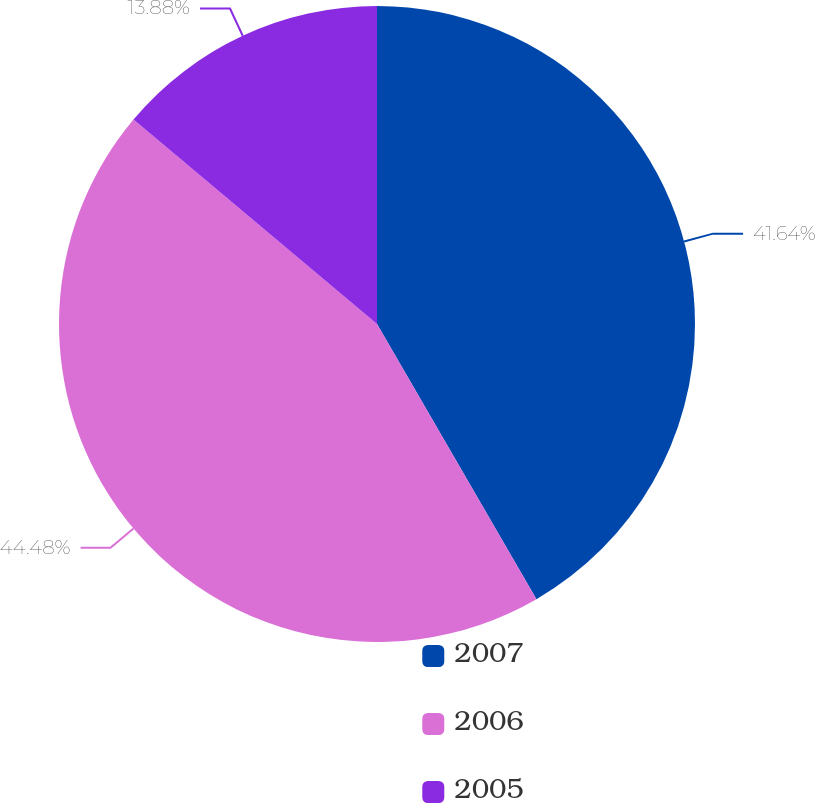<chart> <loc_0><loc_0><loc_500><loc_500><pie_chart><fcel>2007<fcel>2006<fcel>2005<nl><fcel>41.64%<fcel>44.48%<fcel>13.88%<nl></chart> 